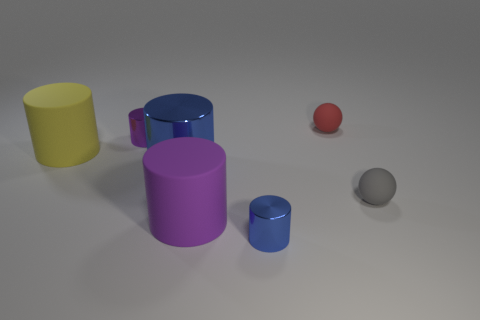The small thing that is both behind the yellow rubber object and in front of the small red rubber thing is made of what material?
Offer a terse response. Metal. What number of small purple metal objects are on the left side of the gray matte sphere?
Provide a short and direct response. 1. What number of big blue things are there?
Keep it short and to the point. 1. Do the purple matte object and the purple metallic object have the same size?
Your answer should be very brief. No. There is a big cylinder that is behind the large metal cylinder behind the small gray rubber object; are there any yellow things in front of it?
Your response must be concise. No. There is a small gray thing that is the same shape as the red matte object; what material is it?
Your answer should be compact. Rubber. What is the color of the big matte cylinder on the right side of the big yellow object?
Keep it short and to the point. Purple. What size is the purple matte object?
Offer a very short reply. Large. Does the gray thing have the same size as the blue metallic object on the left side of the small blue cylinder?
Your answer should be very brief. No. The tiny object that is right of the small rubber ball behind the blue metallic thing that is left of the small blue shiny cylinder is what color?
Provide a short and direct response. Gray. 